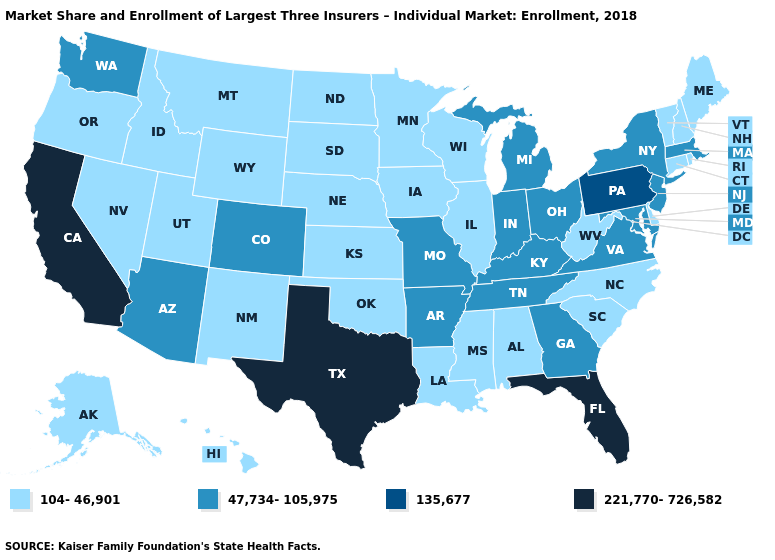Name the states that have a value in the range 104-46,901?
Write a very short answer. Alabama, Alaska, Connecticut, Delaware, Hawaii, Idaho, Illinois, Iowa, Kansas, Louisiana, Maine, Minnesota, Mississippi, Montana, Nebraska, Nevada, New Hampshire, New Mexico, North Carolina, North Dakota, Oklahoma, Oregon, Rhode Island, South Carolina, South Dakota, Utah, Vermont, West Virginia, Wisconsin, Wyoming. Name the states that have a value in the range 47,734-105,975?
Quick response, please. Arizona, Arkansas, Colorado, Georgia, Indiana, Kentucky, Maryland, Massachusetts, Michigan, Missouri, New Jersey, New York, Ohio, Tennessee, Virginia, Washington. Does the first symbol in the legend represent the smallest category?
Give a very brief answer. Yes. Does the map have missing data?
Keep it brief. No. Does Oklahoma have the lowest value in the USA?
Short answer required. Yes. Name the states that have a value in the range 135,677?
Concise answer only. Pennsylvania. Name the states that have a value in the range 221,770-726,582?
Keep it brief. California, Florida, Texas. Name the states that have a value in the range 104-46,901?
Concise answer only. Alabama, Alaska, Connecticut, Delaware, Hawaii, Idaho, Illinois, Iowa, Kansas, Louisiana, Maine, Minnesota, Mississippi, Montana, Nebraska, Nevada, New Hampshire, New Mexico, North Carolina, North Dakota, Oklahoma, Oregon, Rhode Island, South Carolina, South Dakota, Utah, Vermont, West Virginia, Wisconsin, Wyoming. What is the highest value in states that border California?
Give a very brief answer. 47,734-105,975. How many symbols are there in the legend?
Answer briefly. 4. Does the map have missing data?
Concise answer only. No. Does Illinois have a lower value than Idaho?
Concise answer only. No. What is the highest value in the South ?
Give a very brief answer. 221,770-726,582. What is the highest value in the West ?
Be succinct. 221,770-726,582. Which states have the lowest value in the MidWest?
Give a very brief answer. Illinois, Iowa, Kansas, Minnesota, Nebraska, North Dakota, South Dakota, Wisconsin. 